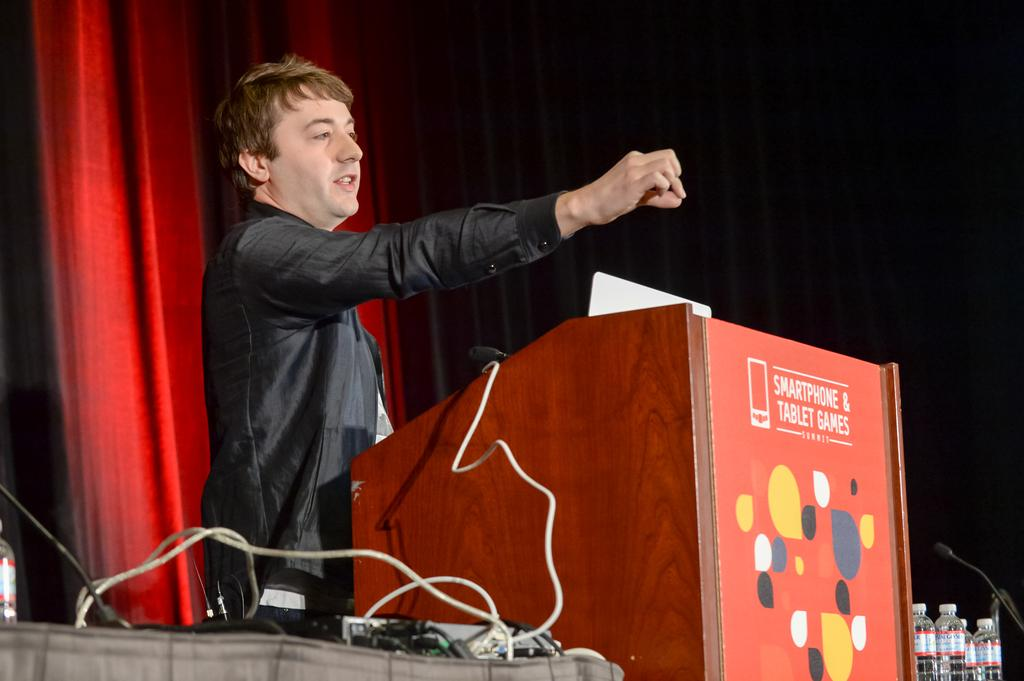What is the man near in the image? The man is standing near a podium in the image. What can be seen on the table in the image? Cables are present on the table in the image. What is visible behind the man in the image? There is a curtain behind the man in the image. What type of jelly is being used as bait in the image? There is no jelly or bait present in the image. What year is depicted in the image? The image does not depict a specific year; it is a still image without any temporal context. 